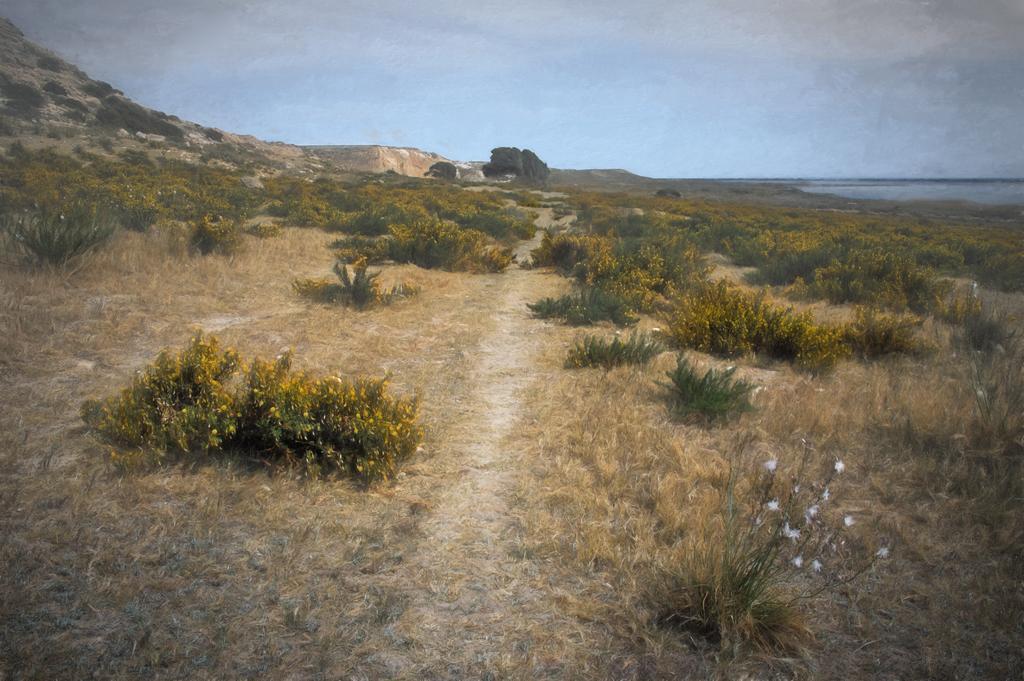Can you describe this image briefly? In this image we can see many plants and few trees. There is a sky in the image. There is a hill in the image. There is a lake in the image. There are flowers to the plants in the image. 